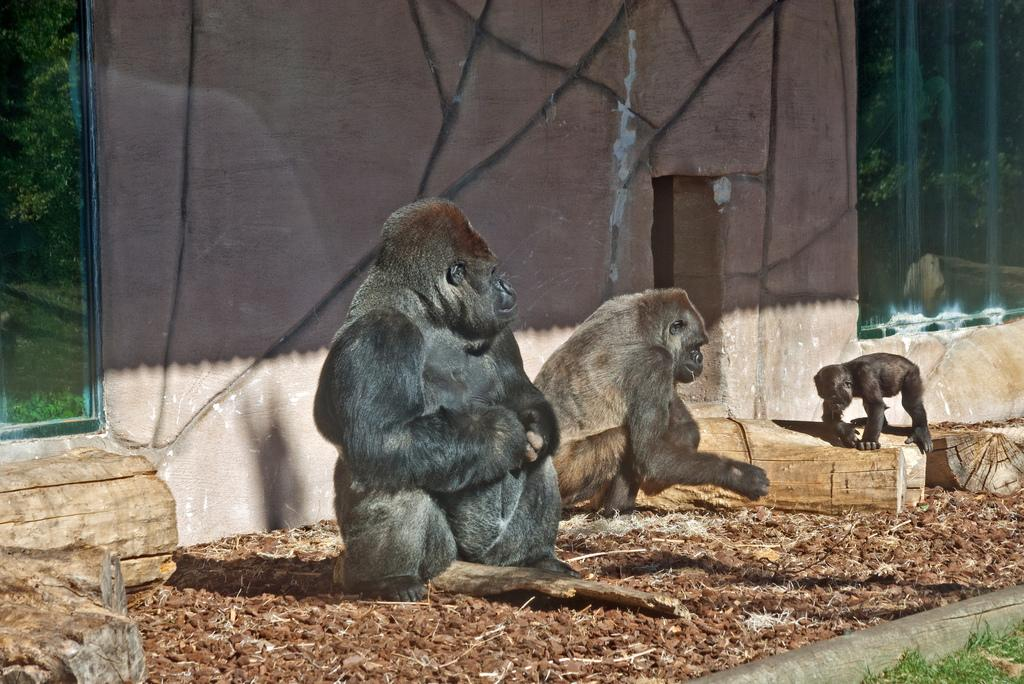What type of animals can be seen on the ground in the image? The image contains animals on the ground, but their specific type is not mentioned. What material are the logs made of in the image? The logs in the image are made of wood. What can be seen in the background of the image? There is a wall and unspecified objects in the background of the image. What is the chin of the animal doing in the image? There is no chin mentioned in the image, as it only contains animals on the ground and wooden logs. 